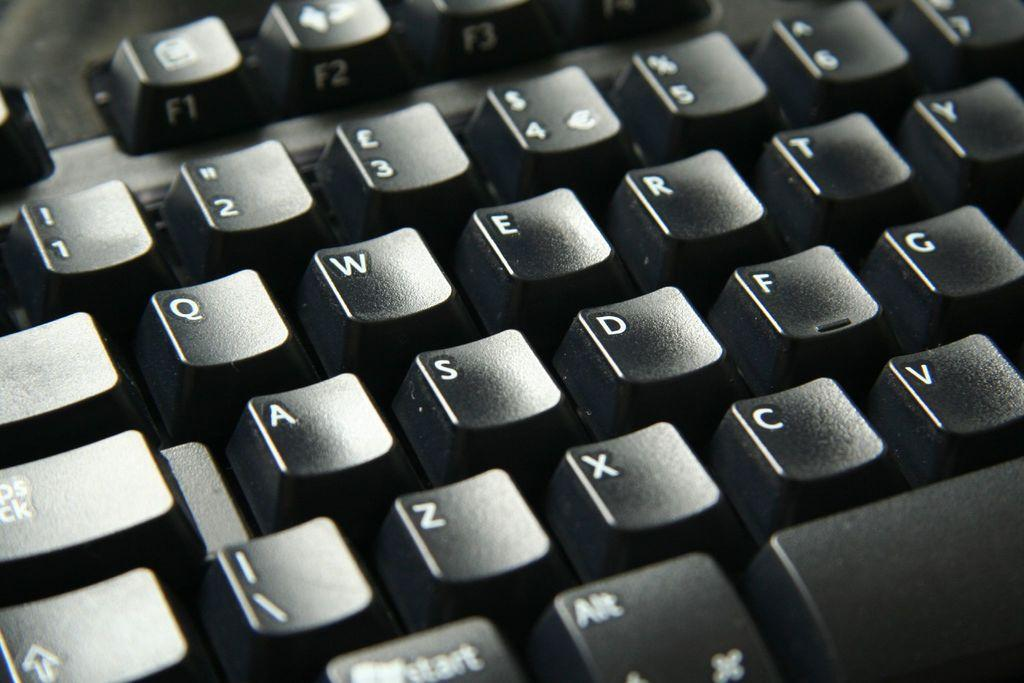<image>
Create a compact narrative representing the image presented. A black keyboard with the letter X C and V is shown 